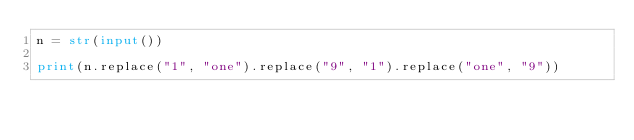Convert code to text. <code><loc_0><loc_0><loc_500><loc_500><_Python_>n = str(input())

print(n.replace("1", "one").replace("9", "1").replace("one", "9"))</code> 